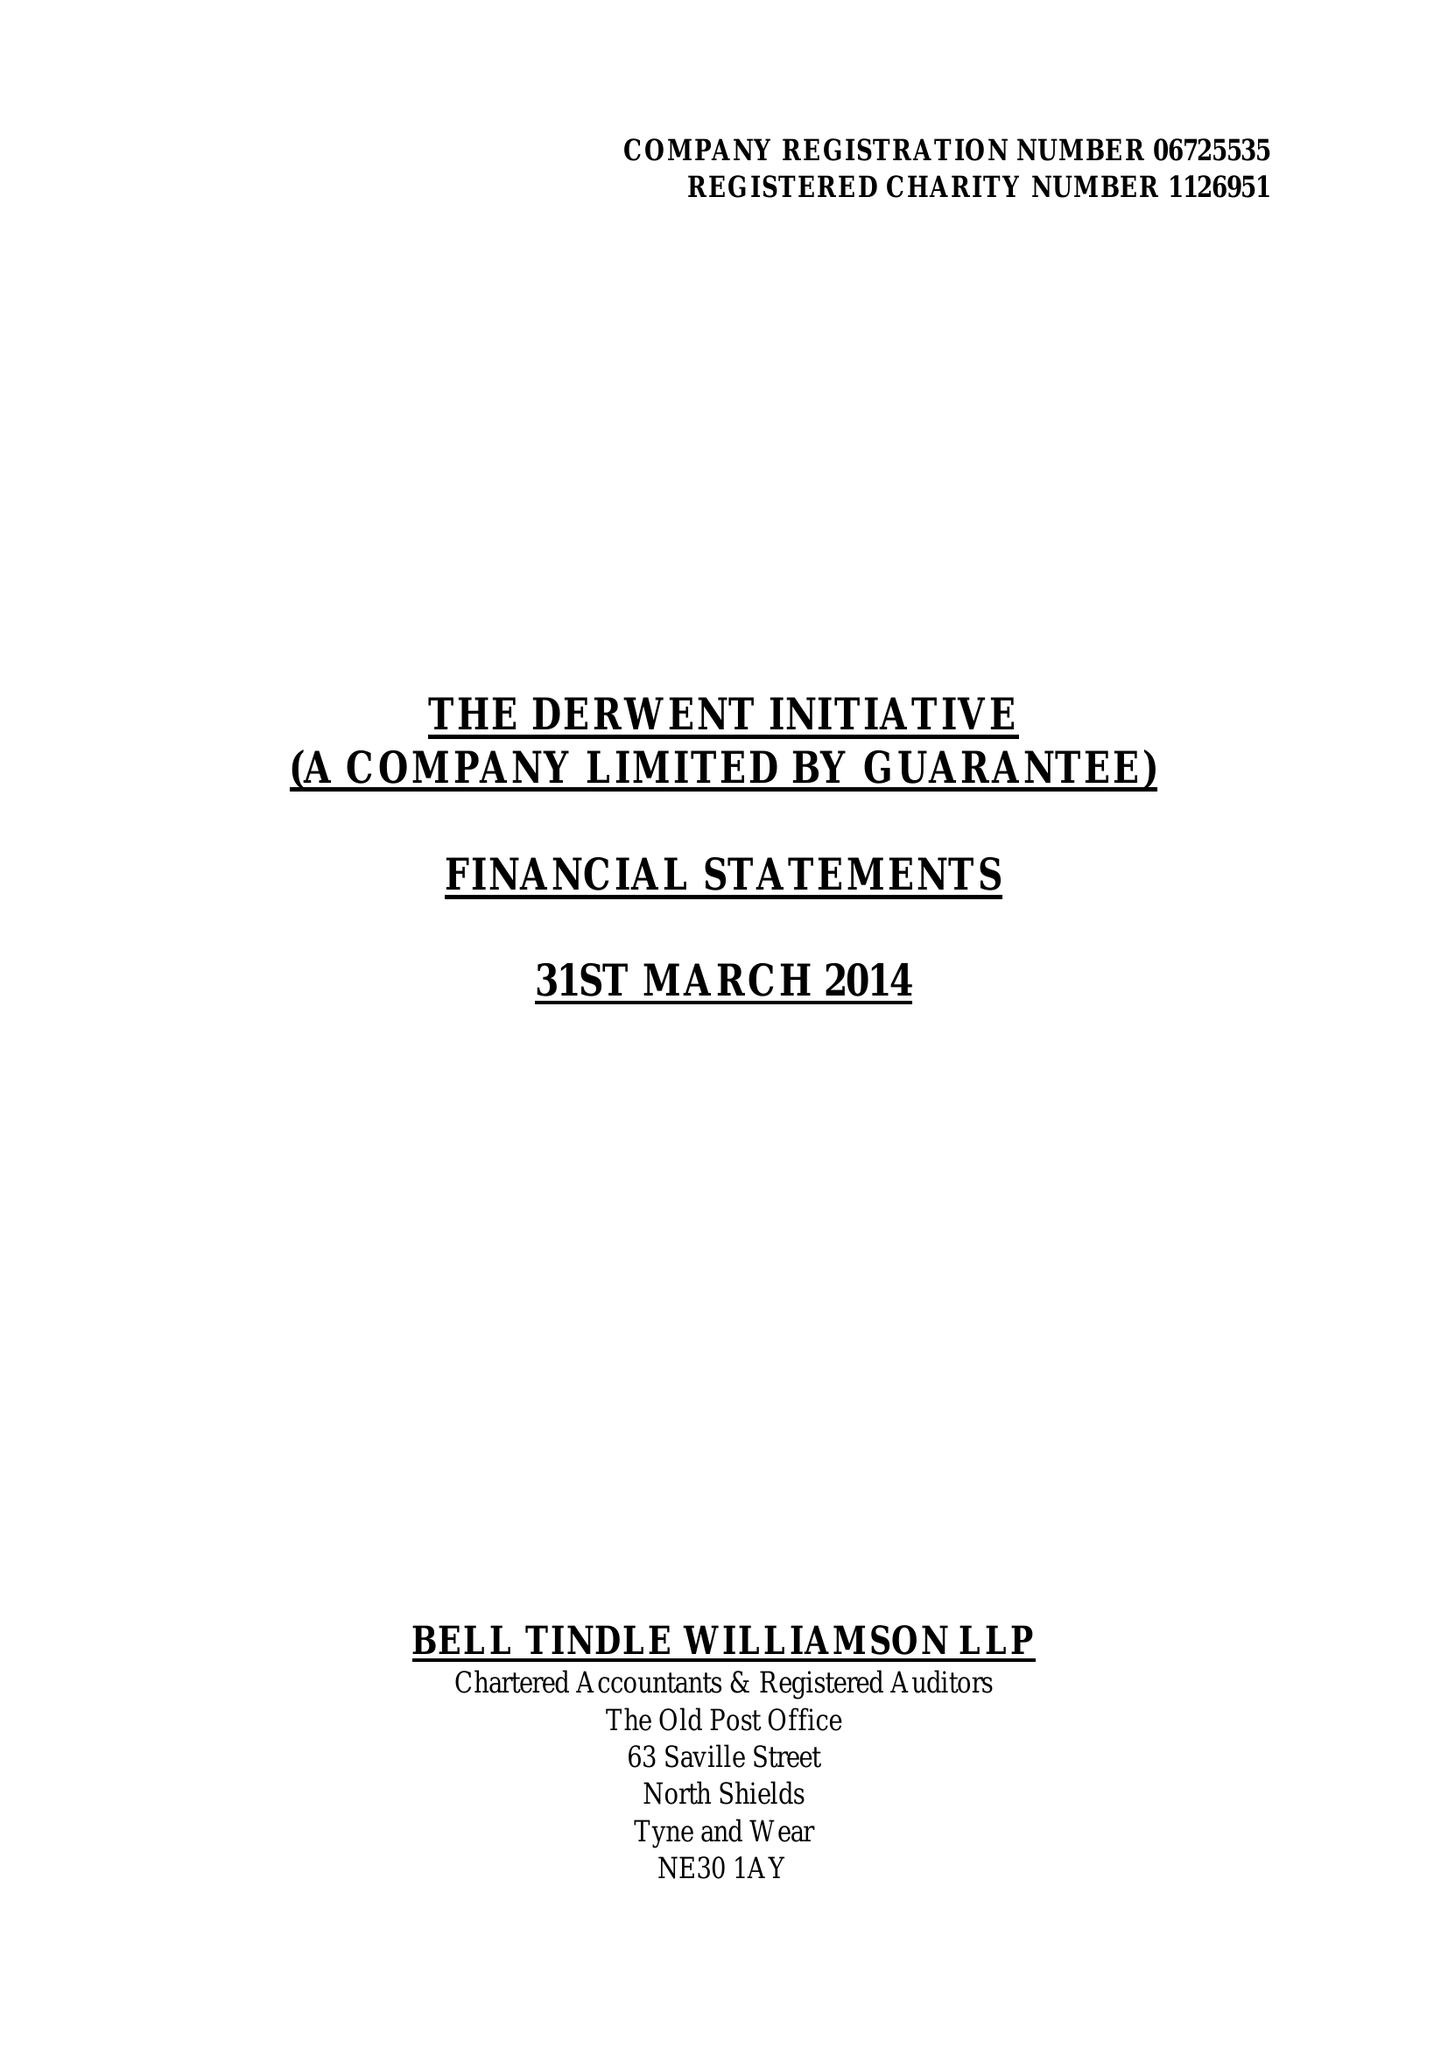What is the value for the address__street_line?
Answer the question using a single word or phrase. None 